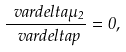Convert formula to latex. <formula><loc_0><loc_0><loc_500><loc_500>\frac { \ v a r d e l t a \mu _ { 2 } } { \ v a r d e l t a p } = 0 ,</formula> 